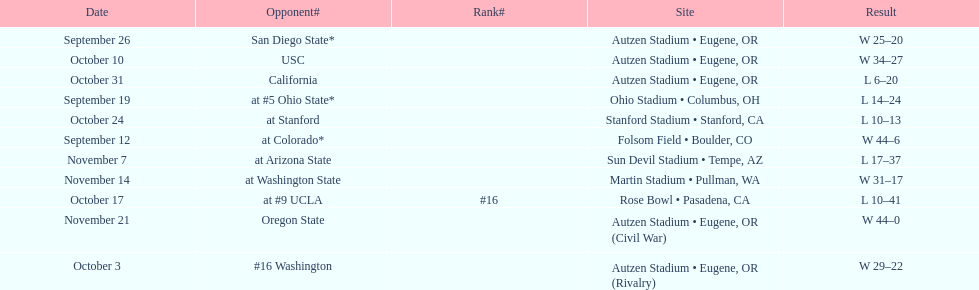Did the team win or lose more games? Win. 